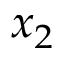<formula> <loc_0><loc_0><loc_500><loc_500>x _ { 2 }</formula> 